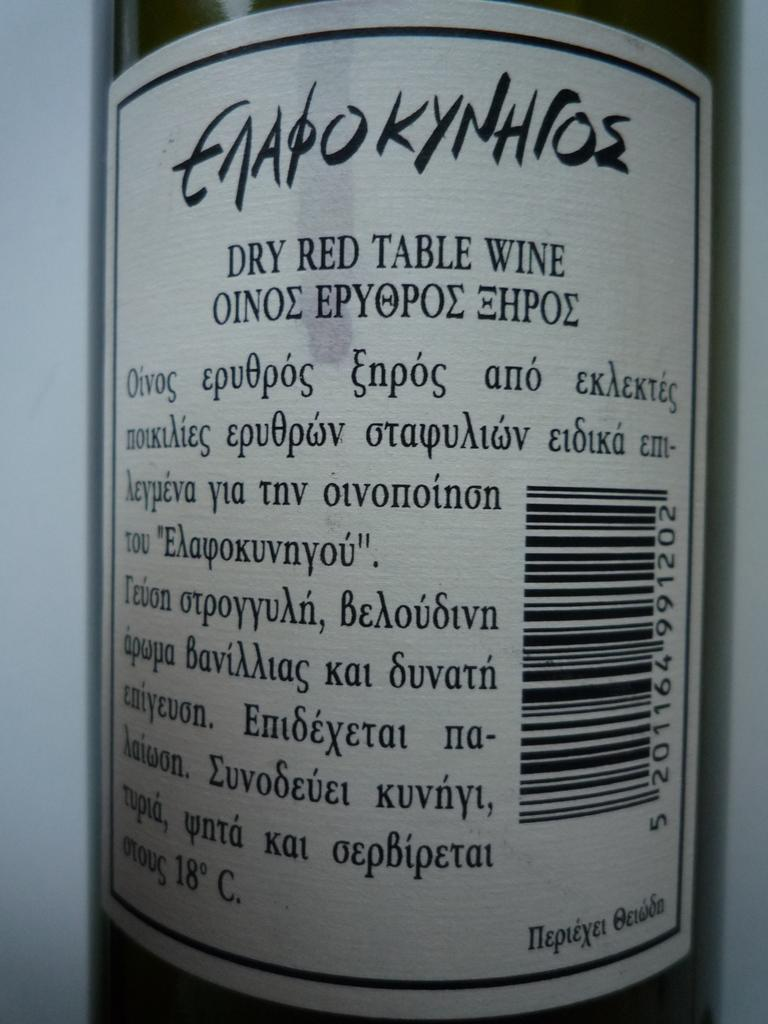<image>
Present a compact description of the photo's key features. A bottle of red wined snamed Enapokyhros is shown. 